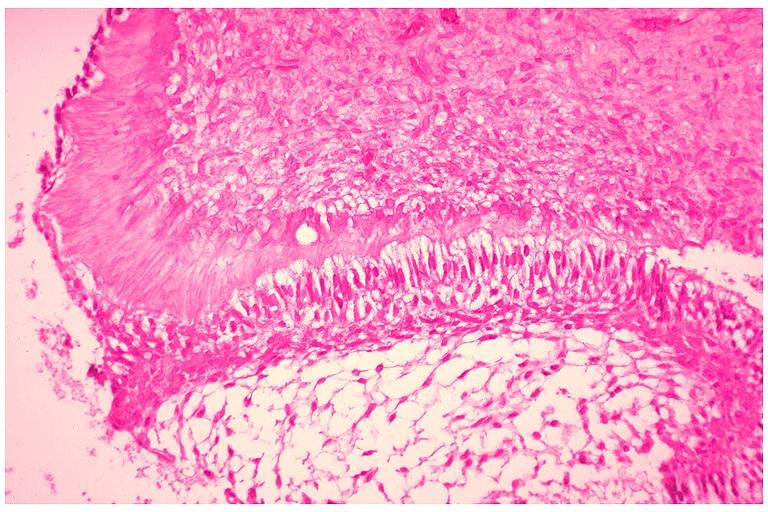where is this?
Answer the question using a single word or phrase. Oral 